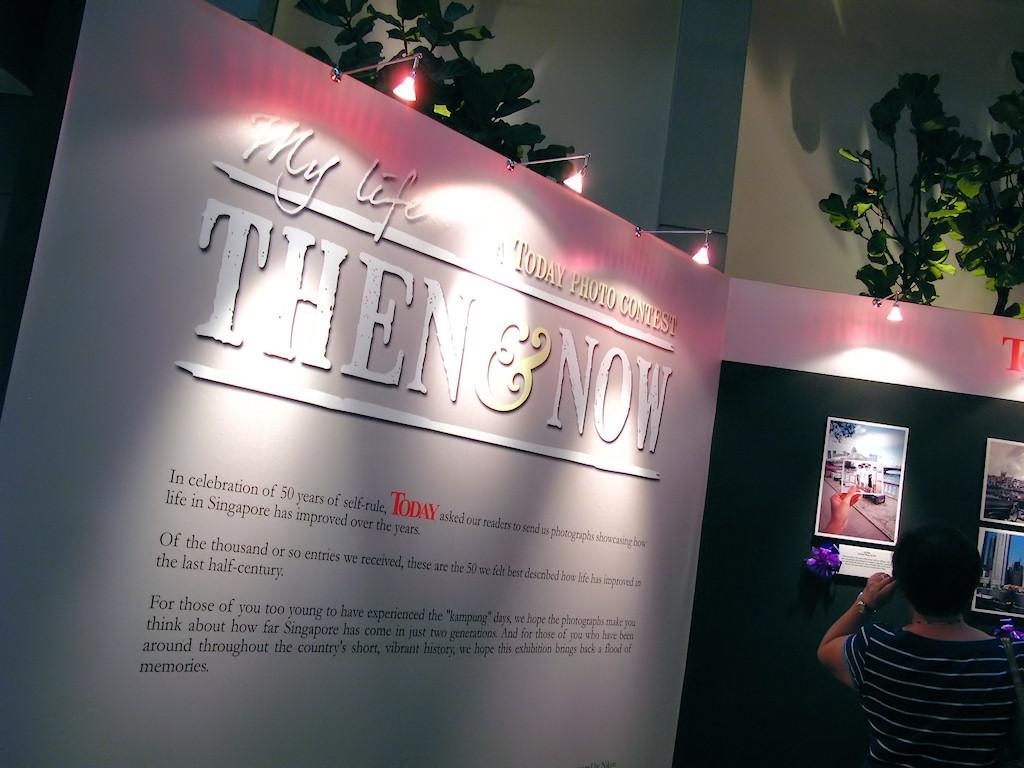What is present in the image along with the person? There is a hoarding in the image. What can be seen on the hoarding? The hoarding contains pictures and some information. What else is visible in the image? There are lights, trees, and a wall in the background. Can you tell me how many parcels are being delivered by the person in the image? There is no indication of a parcel or delivery in the image; the person is not performing any such action. Is there a pail visible in the image? There is no pail present in the image. 